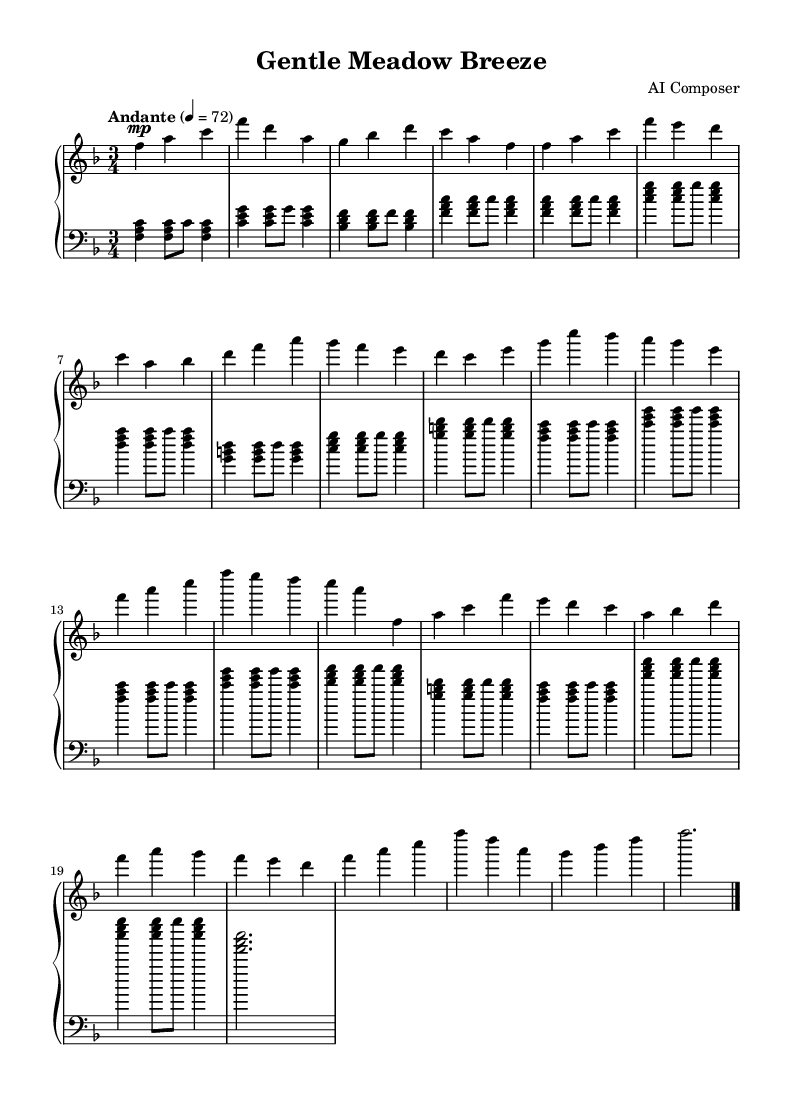What is the key signature of this music? The key signature is F major, which contains one flat (B flat). This can be determined by looking at the key signature indicated in the beginning of the sheet music.
Answer: F major What is the time signature of this piece? The time signature is 3/4, which can be found in the top left corner of the sheet music. It indicates that there are three beats in each measure and the quarter note gets one beat.
Answer: 3/4 What is the tempo marking for this composition? The tempo marking is "Andante" with a metronome marking of 4 = 72. This indicates a moderate speed, often translated as "walking pace." The notation can be found at the beginning of the score.
Answer: Andante, 4 = 72 How many sections are there in the piece? The piece consists of five sections: Introduction, A, B, A', and Coda. By analyzing the structure and repeated themes, we identify these key sections.
Answer: Five What is the dynamic marking of the introduction? The introduction has a dynamic marking of "mp," which means "mezzo-piano," indicating a moderate soft volume. This dynamic can be found at the beginning of the right-hand part in the score.
Answer: Mezzo-piano Which section is labeled as A'? The A' section is the repeat of the A section with slight variations and is marked as such in the sheet music. It appears after the B section, and its designation helps identify it as a return to the main theme with alterations.
Answer: A' What is the final chord of the piece? The final chord is an F major chord, as indicated by the notes F, A, and C played simultaneously in the left hand. This can be recognized in the Coda section where the piece concludes.
Answer: F major 